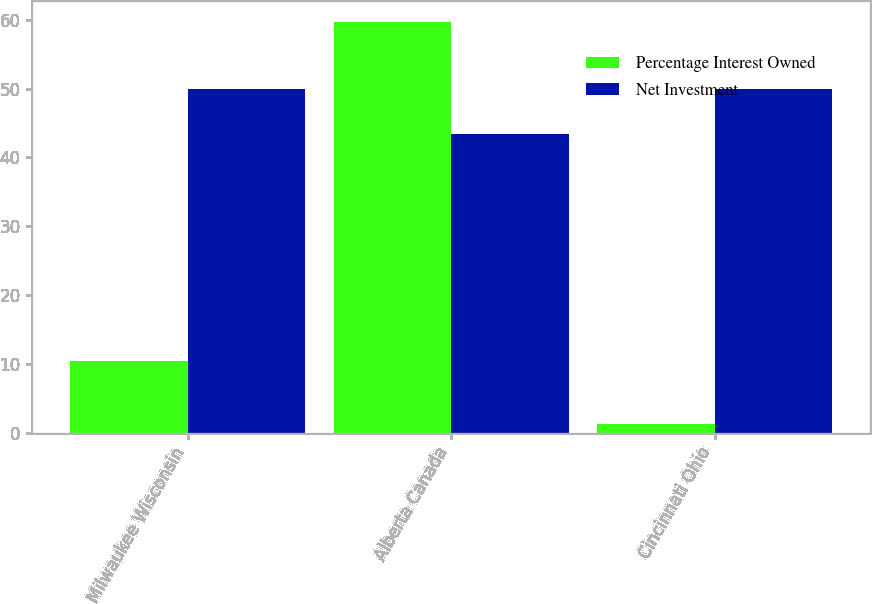Convert chart to OTSL. <chart><loc_0><loc_0><loc_500><loc_500><stacked_bar_chart><ecel><fcel>Milwaukee Wisconsin<fcel>Alberta Canada<fcel>Cincinnati Ohio<nl><fcel>Percentage Interest Owned<fcel>10.4<fcel>59.7<fcel>1.3<nl><fcel>Net Investment<fcel>50<fcel>43.37<fcel>50<nl></chart> 